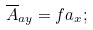Convert formula to latex. <formula><loc_0><loc_0><loc_500><loc_500>\overline { A } _ { a y } = f a _ { x } ;</formula> 